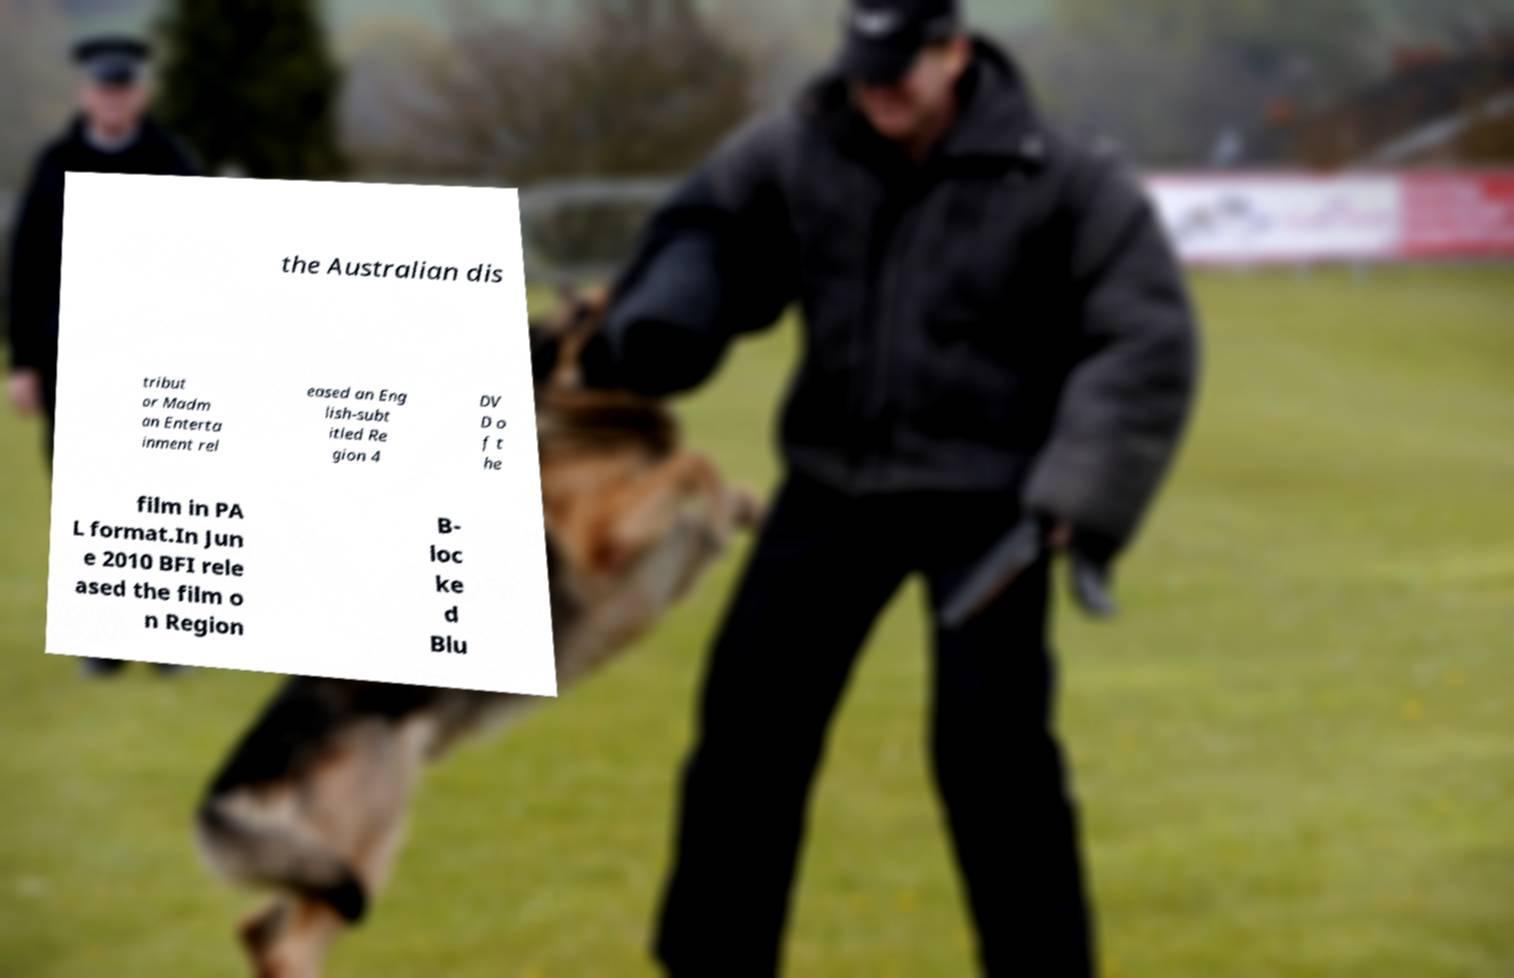Could you extract and type out the text from this image? the Australian dis tribut or Madm an Enterta inment rel eased an Eng lish-subt itled Re gion 4 DV D o f t he film in PA L format.In Jun e 2010 BFI rele ased the film o n Region B- loc ke d Blu 